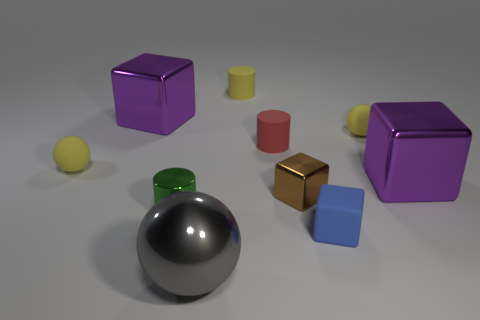Subtract all tiny metallic cylinders. How many cylinders are left? 2 Subtract all brown spheres. How many purple blocks are left? 2 Subtract all blue cubes. How many cubes are left? 3 Subtract all balls. How many objects are left? 7 Subtract 1 spheres. How many spheres are left? 2 Subtract all purple balls. Subtract all yellow cubes. How many balls are left? 3 Subtract all brown shiny objects. Subtract all gray metal objects. How many objects are left? 8 Add 9 tiny green shiny cylinders. How many tiny green shiny cylinders are left? 10 Add 4 yellow balls. How many yellow balls exist? 6 Subtract 1 brown cubes. How many objects are left? 9 